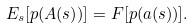<formula> <loc_0><loc_0><loc_500><loc_500>E _ { s } [ p ( A ( s ) ) ] = F [ p ( a ( s ) ) ] .</formula> 